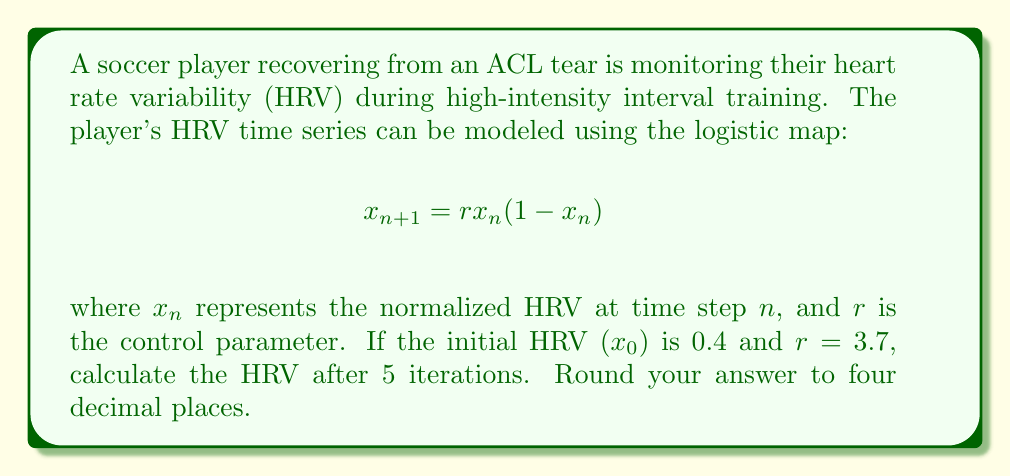Show me your answer to this math problem. To solve this problem, we need to iterate the logistic map equation five times, starting with the initial condition $x_0 = 0.4$ and using $r = 3.7$. Let's go through each iteration step-by-step:

1. First iteration ($n = 0$ to $n = 1$):
   $$x_1 = 3.7 \cdot 0.4 \cdot (1 - 0.4) = 3.7 \cdot 0.4 \cdot 0.6 = 0.888$$

2. Second iteration ($n = 1$ to $n = 2$):
   $$x_2 = 3.7 \cdot 0.888 \cdot (1 - 0.888) = 3.7 \cdot 0.888 \cdot 0.112 = 0.3682752$$

3. Third iteration ($n = 2$ to $n = 3$):
   $$x_3 = 3.7 \cdot 0.3682752 \cdot (1 - 0.3682752) = 3.7 \cdot 0.3682752 \cdot 0.6317248 = 0.8611944$$

4. Fourth iteration ($n = 3$ to $n = 4$):
   $$x_4 = 3.7 \cdot 0.8611944 \cdot (1 - 0.8611944) = 3.7 \cdot 0.8611944 \cdot 0.1388056 = 0.4431875$$

5. Fifth iteration ($n = 4$ to $n = 5$):
   $$x_5 = 3.7 \cdot 0.4431875 \cdot (1 - 0.4431875) = 3.7 \cdot 0.4431875 \cdot 0.5568125 = 0.9132109$$

The final result after 5 iterations is 0.9132109. Rounding to four decimal places gives us 0.9132.
Answer: 0.9132 